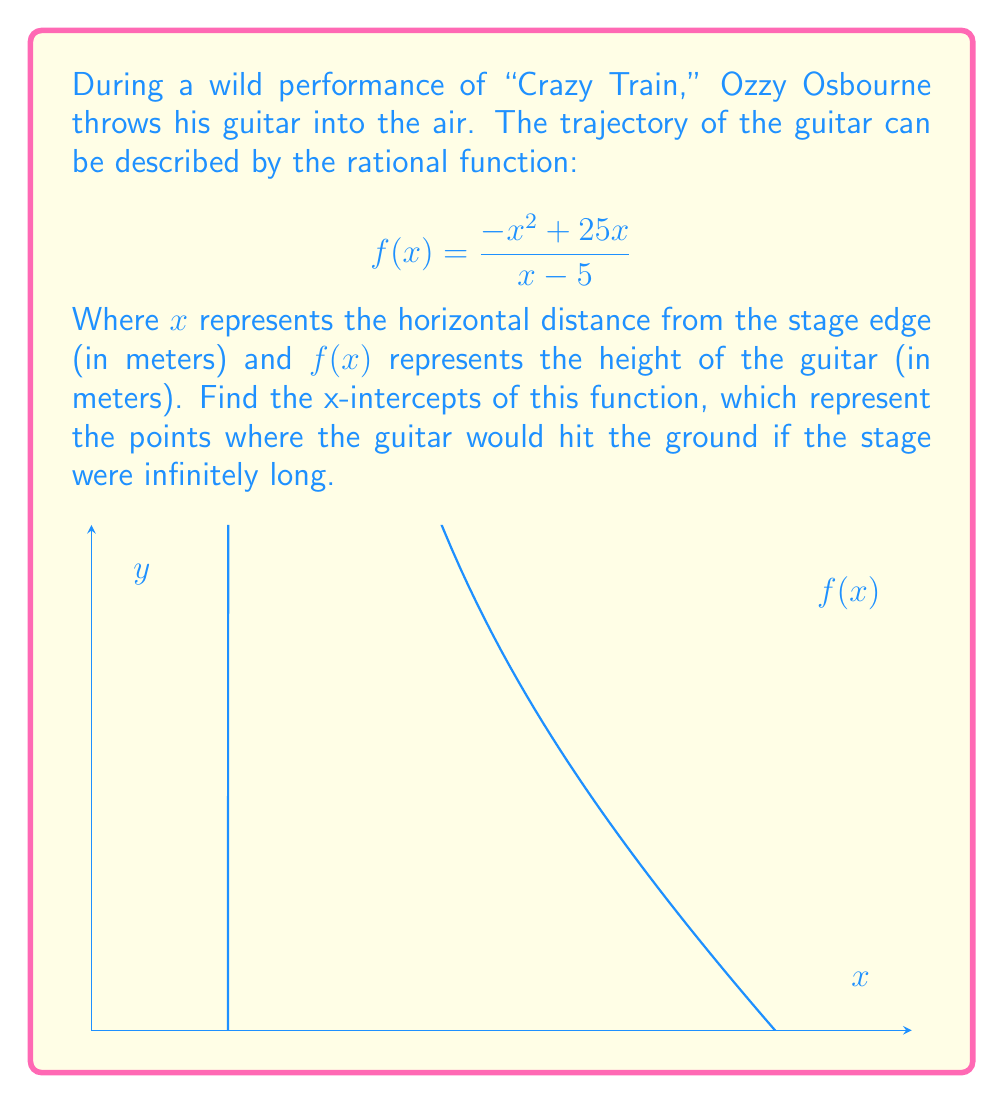What is the answer to this math problem? To find the x-intercepts, we need to solve the equation $f(x) = 0$:

1) Set up the equation:
   $$\frac{-x^2 + 25x}{x - 5} = 0$$

2) For a fraction to be zero, its numerator must be zero (assuming the denominator is not undefined):
   $$-x^2 + 25x = 0$$

3) Factor out the common factor:
   $$x(-x + 25) = 0$$

4) Use the zero product property. Either $x = 0$ or $-x + 25 = 0$:
   
   $x = 0$ or $x = 25$

5) Check if these solutions satisfy the original function:
   - $x = 0$ works in the original function.
   - $x = 25$ works in the original function.

6) Note that $x = 5$ is not a valid x-intercept because it makes the denominator zero, creating an undefined point (vertical asymptote).

Therefore, the x-intercepts are at $x = 0$ and $x = 25$.
Answer: $x = 0$ and $x = 25$ 